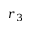Convert formula to latex. <formula><loc_0><loc_0><loc_500><loc_500>r _ { 3 }</formula> 